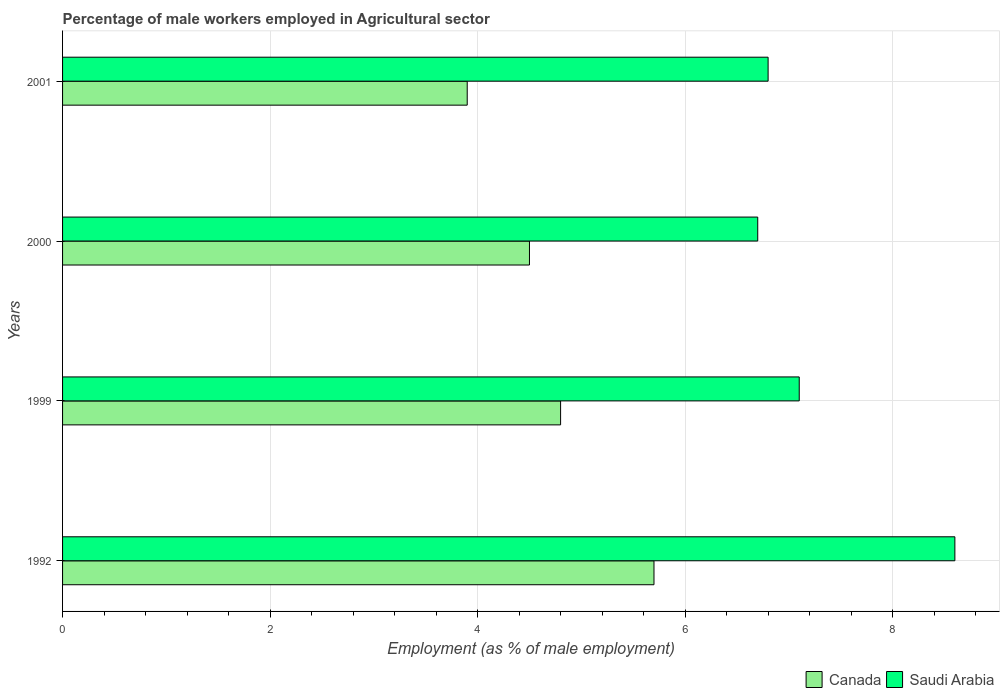How many different coloured bars are there?
Keep it short and to the point. 2. How many groups of bars are there?
Your answer should be very brief. 4. Are the number of bars per tick equal to the number of legend labels?
Keep it short and to the point. Yes. What is the label of the 3rd group of bars from the top?
Your answer should be compact. 1999. What is the percentage of male workers employed in Agricultural sector in Saudi Arabia in 2001?
Offer a terse response. 6.8. Across all years, what is the maximum percentage of male workers employed in Agricultural sector in Saudi Arabia?
Provide a succinct answer. 8.6. Across all years, what is the minimum percentage of male workers employed in Agricultural sector in Canada?
Provide a short and direct response. 3.9. In which year was the percentage of male workers employed in Agricultural sector in Canada maximum?
Your answer should be compact. 1992. What is the total percentage of male workers employed in Agricultural sector in Canada in the graph?
Provide a short and direct response. 18.9. What is the difference between the percentage of male workers employed in Agricultural sector in Saudi Arabia in 1999 and that in 2001?
Provide a succinct answer. 0.3. What is the average percentage of male workers employed in Agricultural sector in Canada per year?
Make the answer very short. 4.73. In the year 1999, what is the difference between the percentage of male workers employed in Agricultural sector in Canada and percentage of male workers employed in Agricultural sector in Saudi Arabia?
Provide a short and direct response. -2.3. In how many years, is the percentage of male workers employed in Agricultural sector in Canada greater than 0.8 %?
Provide a succinct answer. 4. What is the ratio of the percentage of male workers employed in Agricultural sector in Saudi Arabia in 1992 to that in 1999?
Make the answer very short. 1.21. Is the percentage of male workers employed in Agricultural sector in Saudi Arabia in 1992 less than that in 1999?
Your answer should be compact. No. What is the difference between the highest and the second highest percentage of male workers employed in Agricultural sector in Saudi Arabia?
Offer a very short reply. 1.5. What is the difference between the highest and the lowest percentage of male workers employed in Agricultural sector in Saudi Arabia?
Ensure brevity in your answer.  1.9. Is the sum of the percentage of male workers employed in Agricultural sector in Canada in 1999 and 2001 greater than the maximum percentage of male workers employed in Agricultural sector in Saudi Arabia across all years?
Offer a very short reply. Yes. What does the 2nd bar from the top in 1992 represents?
Offer a very short reply. Canada. What does the 1st bar from the bottom in 2001 represents?
Offer a terse response. Canada. How many bars are there?
Your response must be concise. 8. Are the values on the major ticks of X-axis written in scientific E-notation?
Offer a very short reply. No. Where does the legend appear in the graph?
Ensure brevity in your answer.  Bottom right. How are the legend labels stacked?
Give a very brief answer. Horizontal. What is the title of the graph?
Your response must be concise. Percentage of male workers employed in Agricultural sector. What is the label or title of the X-axis?
Provide a succinct answer. Employment (as % of male employment). What is the label or title of the Y-axis?
Your response must be concise. Years. What is the Employment (as % of male employment) of Canada in 1992?
Ensure brevity in your answer.  5.7. What is the Employment (as % of male employment) in Saudi Arabia in 1992?
Give a very brief answer. 8.6. What is the Employment (as % of male employment) of Canada in 1999?
Your response must be concise. 4.8. What is the Employment (as % of male employment) of Saudi Arabia in 1999?
Offer a terse response. 7.1. What is the Employment (as % of male employment) of Saudi Arabia in 2000?
Your answer should be very brief. 6.7. What is the Employment (as % of male employment) of Canada in 2001?
Ensure brevity in your answer.  3.9. What is the Employment (as % of male employment) in Saudi Arabia in 2001?
Provide a succinct answer. 6.8. Across all years, what is the maximum Employment (as % of male employment) of Canada?
Give a very brief answer. 5.7. Across all years, what is the maximum Employment (as % of male employment) in Saudi Arabia?
Your answer should be compact. 8.6. Across all years, what is the minimum Employment (as % of male employment) of Canada?
Offer a terse response. 3.9. Across all years, what is the minimum Employment (as % of male employment) in Saudi Arabia?
Offer a terse response. 6.7. What is the total Employment (as % of male employment) in Canada in the graph?
Your answer should be very brief. 18.9. What is the total Employment (as % of male employment) in Saudi Arabia in the graph?
Provide a succinct answer. 29.2. What is the difference between the Employment (as % of male employment) of Canada in 1992 and that in 1999?
Offer a very short reply. 0.9. What is the difference between the Employment (as % of male employment) in Canada in 1992 and that in 2000?
Keep it short and to the point. 1.2. What is the difference between the Employment (as % of male employment) of Saudi Arabia in 1992 and that in 2000?
Make the answer very short. 1.9. What is the difference between the Employment (as % of male employment) of Saudi Arabia in 1992 and that in 2001?
Your answer should be very brief. 1.8. What is the difference between the Employment (as % of male employment) of Saudi Arabia in 1999 and that in 2000?
Ensure brevity in your answer.  0.4. What is the difference between the Employment (as % of male employment) in Canada in 1992 and the Employment (as % of male employment) in Saudi Arabia in 2001?
Ensure brevity in your answer.  -1.1. What is the average Employment (as % of male employment) of Canada per year?
Your answer should be very brief. 4.72. What is the average Employment (as % of male employment) of Saudi Arabia per year?
Your answer should be very brief. 7.3. In the year 1992, what is the difference between the Employment (as % of male employment) in Canada and Employment (as % of male employment) in Saudi Arabia?
Provide a succinct answer. -2.9. In the year 1999, what is the difference between the Employment (as % of male employment) in Canada and Employment (as % of male employment) in Saudi Arabia?
Give a very brief answer. -2.3. In the year 2000, what is the difference between the Employment (as % of male employment) in Canada and Employment (as % of male employment) in Saudi Arabia?
Ensure brevity in your answer.  -2.2. In the year 2001, what is the difference between the Employment (as % of male employment) of Canada and Employment (as % of male employment) of Saudi Arabia?
Offer a terse response. -2.9. What is the ratio of the Employment (as % of male employment) in Canada in 1992 to that in 1999?
Offer a very short reply. 1.19. What is the ratio of the Employment (as % of male employment) in Saudi Arabia in 1992 to that in 1999?
Give a very brief answer. 1.21. What is the ratio of the Employment (as % of male employment) in Canada in 1992 to that in 2000?
Make the answer very short. 1.27. What is the ratio of the Employment (as % of male employment) in Saudi Arabia in 1992 to that in 2000?
Give a very brief answer. 1.28. What is the ratio of the Employment (as % of male employment) of Canada in 1992 to that in 2001?
Ensure brevity in your answer.  1.46. What is the ratio of the Employment (as % of male employment) in Saudi Arabia in 1992 to that in 2001?
Keep it short and to the point. 1.26. What is the ratio of the Employment (as % of male employment) in Canada in 1999 to that in 2000?
Keep it short and to the point. 1.07. What is the ratio of the Employment (as % of male employment) in Saudi Arabia in 1999 to that in 2000?
Your answer should be compact. 1.06. What is the ratio of the Employment (as % of male employment) of Canada in 1999 to that in 2001?
Offer a very short reply. 1.23. What is the ratio of the Employment (as % of male employment) in Saudi Arabia in 1999 to that in 2001?
Offer a terse response. 1.04. What is the ratio of the Employment (as % of male employment) of Canada in 2000 to that in 2001?
Your response must be concise. 1.15. What is the difference between the highest and the lowest Employment (as % of male employment) in Canada?
Offer a terse response. 1.8. 